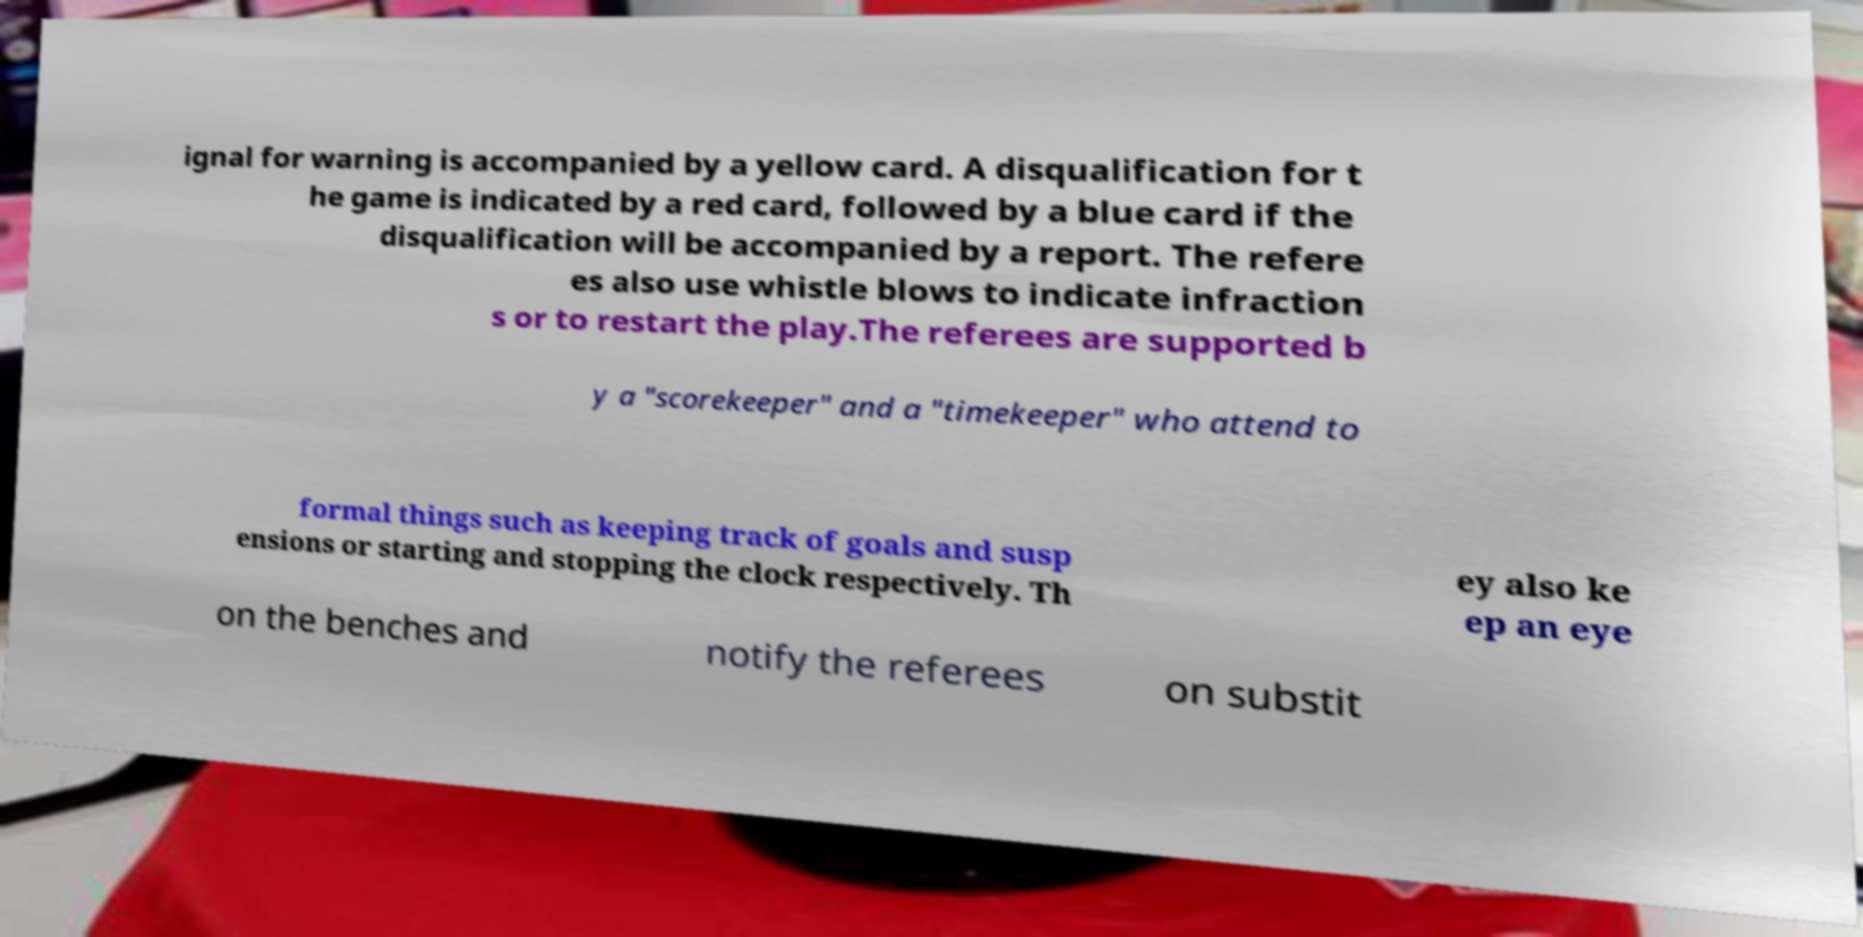What messages or text are displayed in this image? I need them in a readable, typed format. ignal for warning is accompanied by a yellow card. A disqualification for t he game is indicated by a red card, followed by a blue card if the disqualification will be accompanied by a report. The refere es also use whistle blows to indicate infraction s or to restart the play.The referees are supported b y a "scorekeeper" and a "timekeeper" who attend to formal things such as keeping track of goals and susp ensions or starting and stopping the clock respectively. Th ey also ke ep an eye on the benches and notify the referees on substit 